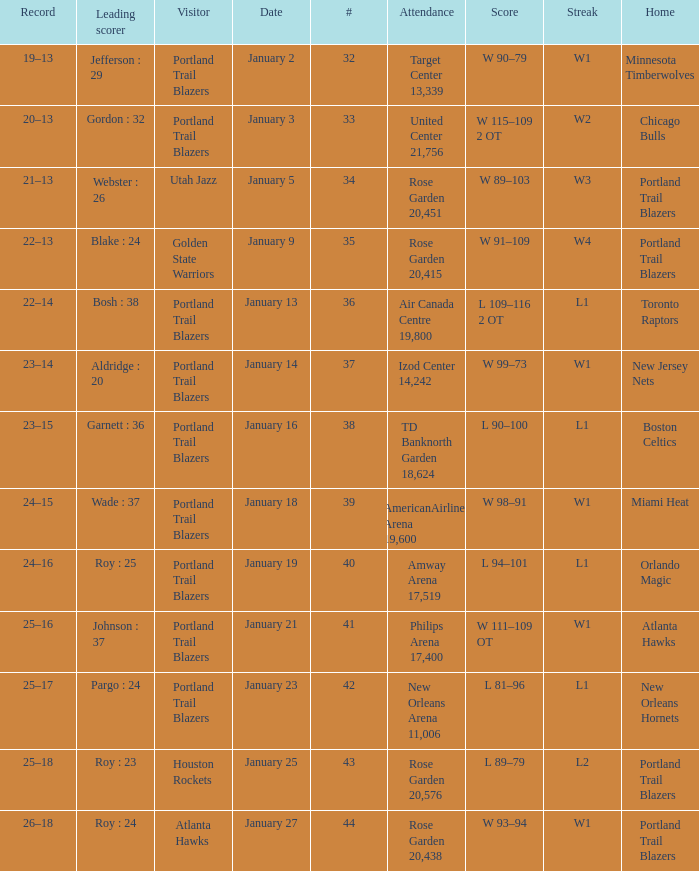Which visitors have a leading scorer of roy : 25 Portland Trail Blazers. 